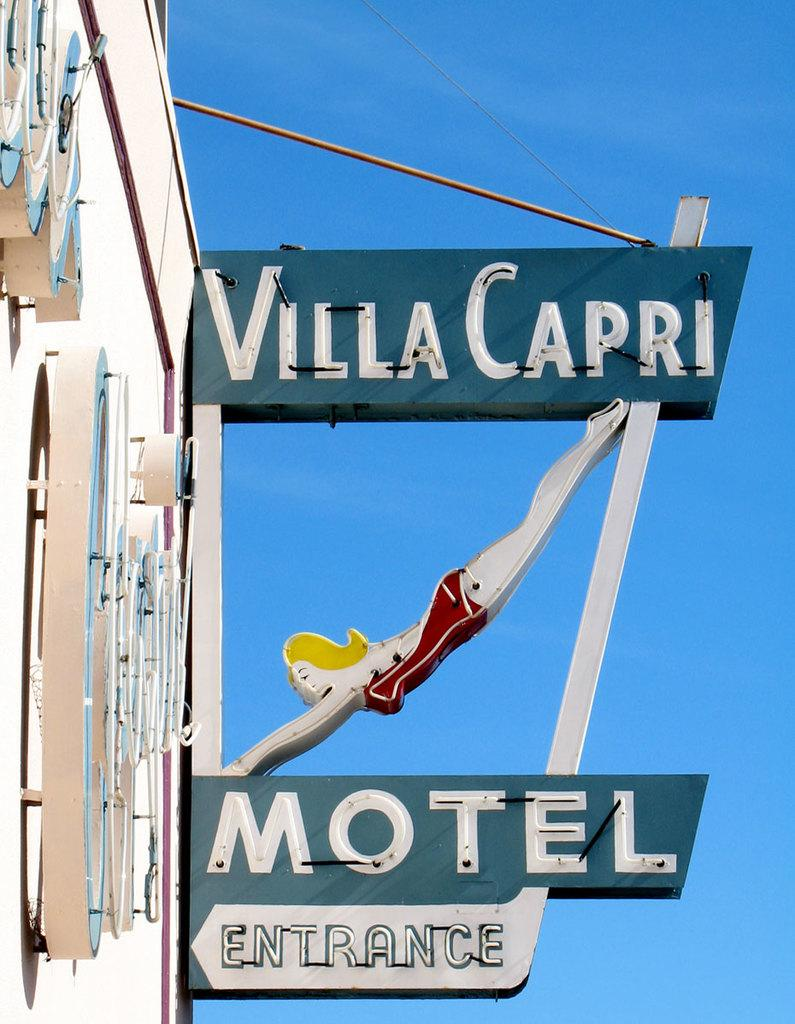<image>
Relay a brief, clear account of the picture shown. The Villa Capri Motel sign features a neon diving woman on it. 